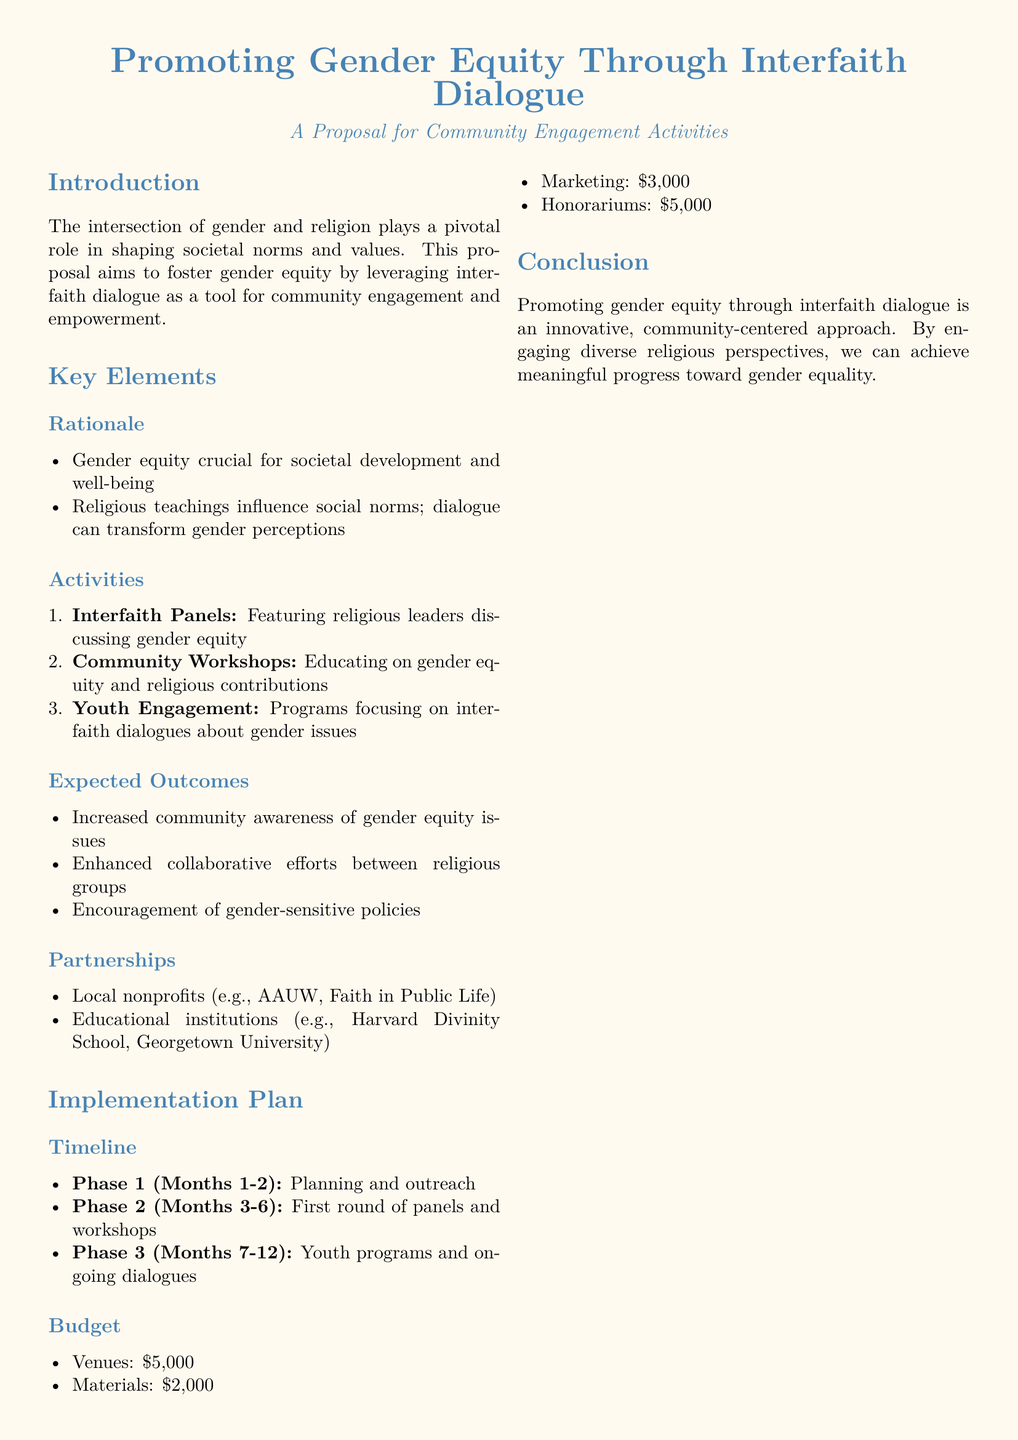What is the main focus of the proposal? The proposal aims to foster gender equity by leveraging interfaith dialogue as a tool for community engagement and empowerment.
Answer: Gender equity through interfaith dialogue How many phases are outlined in the implementation plan? The implementation plan describes three distinct phases.
Answer: 3 What is the budget allocated for venues? The document specifies a budget of $5,000 allocated for venues.
Answer: $5,000 What is one expected outcome of the proposed activities? The proposal mentions increased community awareness of gender equity issues as an expected outcome.
Answer: Increased community awareness Which two types of organizations are proposed for partnerships? Local nonprofits and educational institutions are suggested for partnerships in the proposal.
Answer: Local nonprofits and educational institutions What is the duration of Phase 1 in the implementation plan? Phase 1 is set to last for 2 months, from Month 1 to Month 2.
Answer: 2 months What type of activities are proposed for youth engagement? The activities proposed for youth engagement focus on interfaith dialogues about gender issues.
Answer: Interfaith dialogues about gender issues Who is invited to join the initiative? The document invites community leaders, religious institutions, and local organizations to participate in the initiative.
Answer: Community leaders, religious institutions, and local organizations 